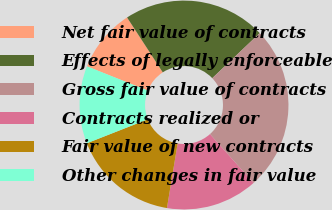<chart> <loc_0><loc_0><loc_500><loc_500><pie_chart><fcel>Net fair value of contracts<fcel>Effects of legally enforceable<fcel>Gross fair value of contracts<fcel>Contracts realized or<fcel>Fair value of new contracts<fcel>Other changes in fair value<nl><fcel>9.79%<fcel>22.09%<fcel>25.49%<fcel>14.21%<fcel>16.42%<fcel>12.0%<nl></chart> 